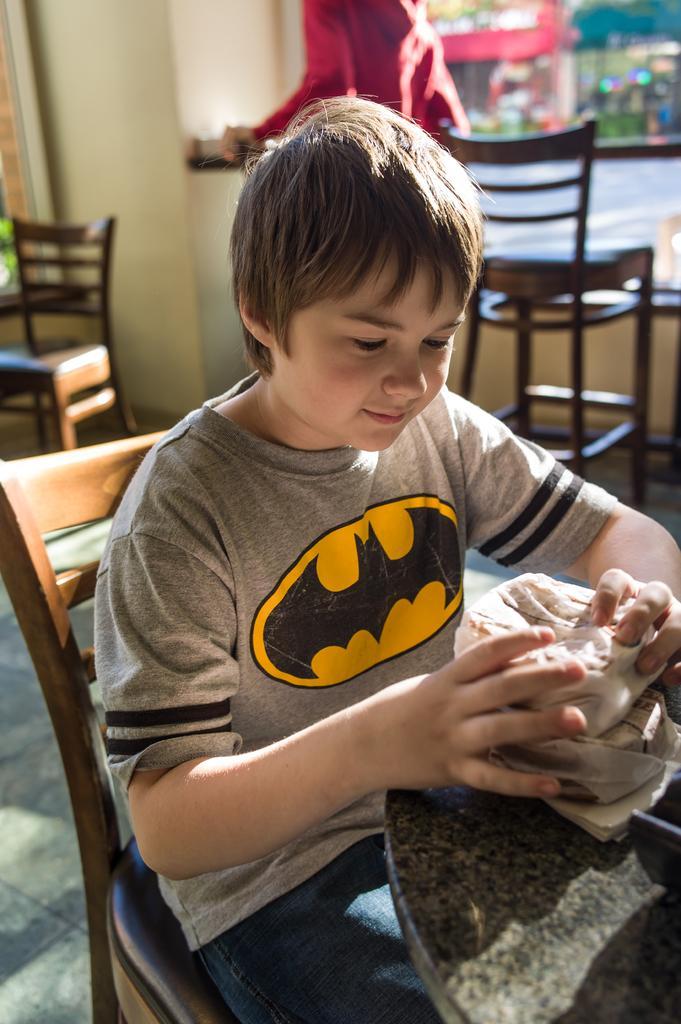Could you give a brief overview of what you see in this image? In this picture we can see a boy sitting on a chair and smiling and in front of him we can see a table and in the background we can see chairs and it is blurry. 